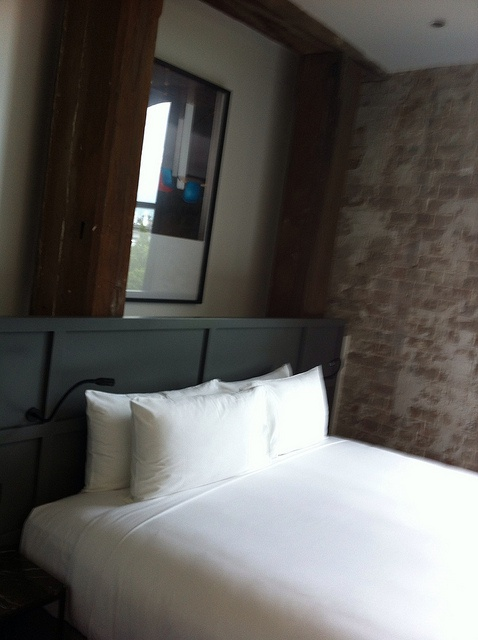Describe the objects in this image and their specific colors. I can see a bed in gray, white, darkgray, and black tones in this image. 